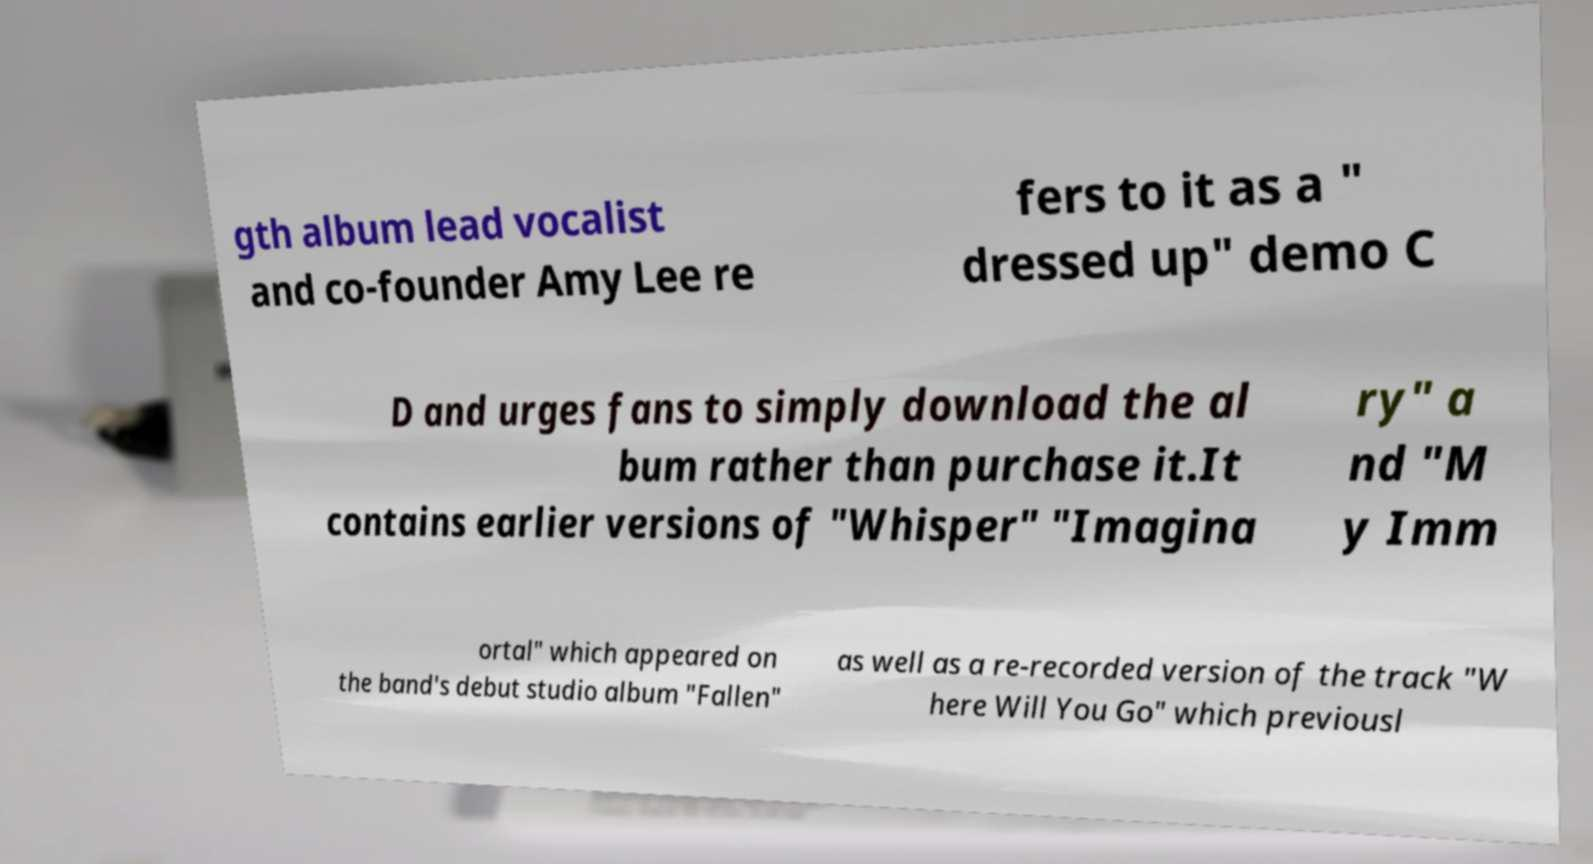Please identify and transcribe the text found in this image. gth album lead vocalist and co-founder Amy Lee re fers to it as a " dressed up" demo C D and urges fans to simply download the al bum rather than purchase it.It contains earlier versions of "Whisper" "Imagina ry" a nd "M y Imm ortal" which appeared on the band's debut studio album "Fallen" as well as a re-recorded version of the track "W here Will You Go" which previousl 